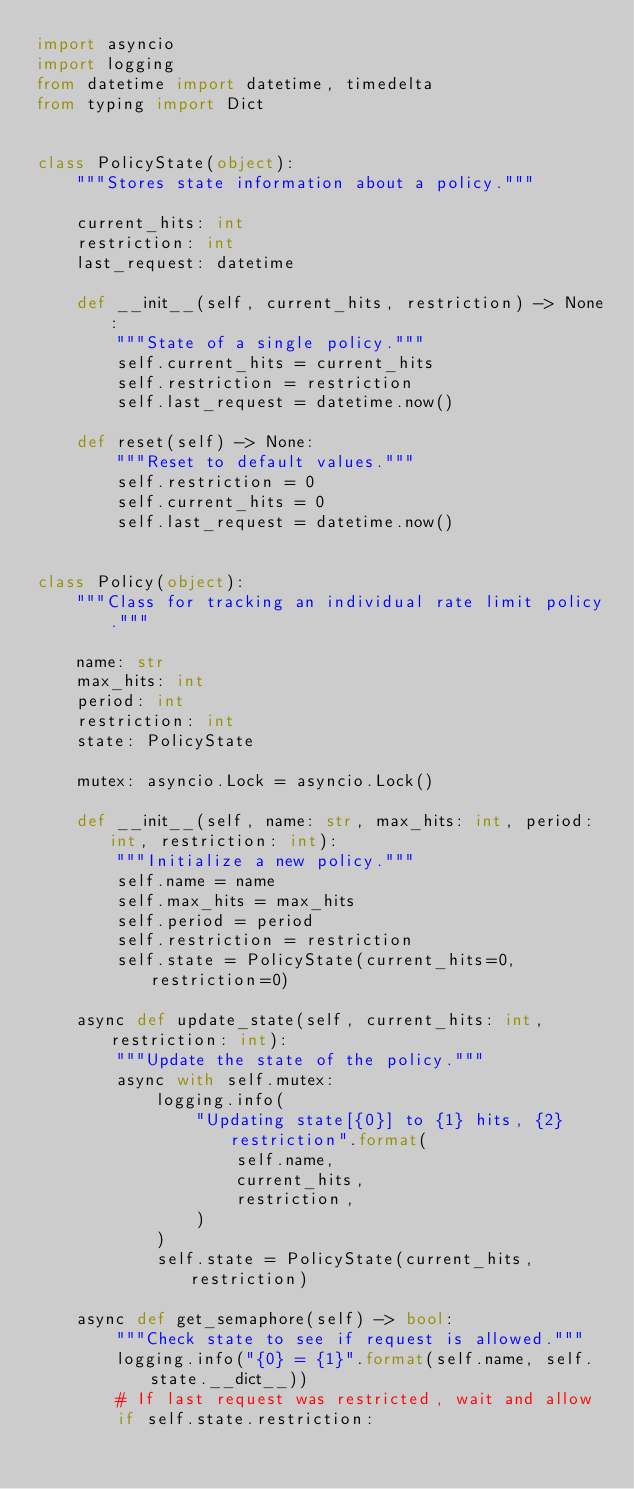Convert code to text. <code><loc_0><loc_0><loc_500><loc_500><_Python_>import asyncio
import logging
from datetime import datetime, timedelta
from typing import Dict


class PolicyState(object):
    """Stores state information about a policy."""

    current_hits: int
    restriction: int
    last_request: datetime

    def __init__(self, current_hits, restriction) -> None:
        """State of a single policy."""
        self.current_hits = current_hits
        self.restriction = restriction
        self.last_request = datetime.now()

    def reset(self) -> None:
        """Reset to default values."""
        self.restriction = 0
        self.current_hits = 0
        self.last_request = datetime.now()


class Policy(object):
    """Class for tracking an individual rate limit policy."""

    name: str
    max_hits: int
    period: int
    restriction: int
    state: PolicyState

    mutex: asyncio.Lock = asyncio.Lock()

    def __init__(self, name: str, max_hits: int, period: int, restriction: int):
        """Initialize a new policy."""
        self.name = name
        self.max_hits = max_hits
        self.period = period
        self.restriction = restriction
        self.state = PolicyState(current_hits=0, restriction=0)

    async def update_state(self, current_hits: int, restriction: int):
        """Update the state of the policy."""
        async with self.mutex:
            logging.info(
                "Updating state[{0}] to {1} hits, {2} restriction".format(
                    self.name,
                    current_hits,
                    restriction,
                )
            )
            self.state = PolicyState(current_hits, restriction)

    async def get_semaphore(self) -> bool:
        """Check state to see if request is allowed."""
        logging.info("{0} = {1}".format(self.name, self.state.__dict__))
        # If last request was restricted, wait and allow
        if self.state.restriction:</code> 